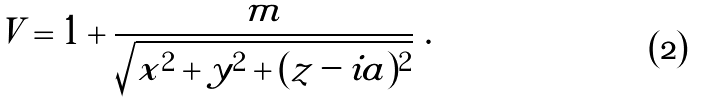Convert formula to latex. <formula><loc_0><loc_0><loc_500><loc_500>V = 1 + { \frac { m } { \sqrt { x ^ { 2 } + y ^ { 2 } + ( z - i a ) ^ { 2 } } } } \ .</formula> 